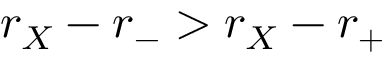Convert formula to latex. <formula><loc_0><loc_0><loc_500><loc_500>r _ { X } - r _ { - } > r _ { X } - r _ { + }</formula> 